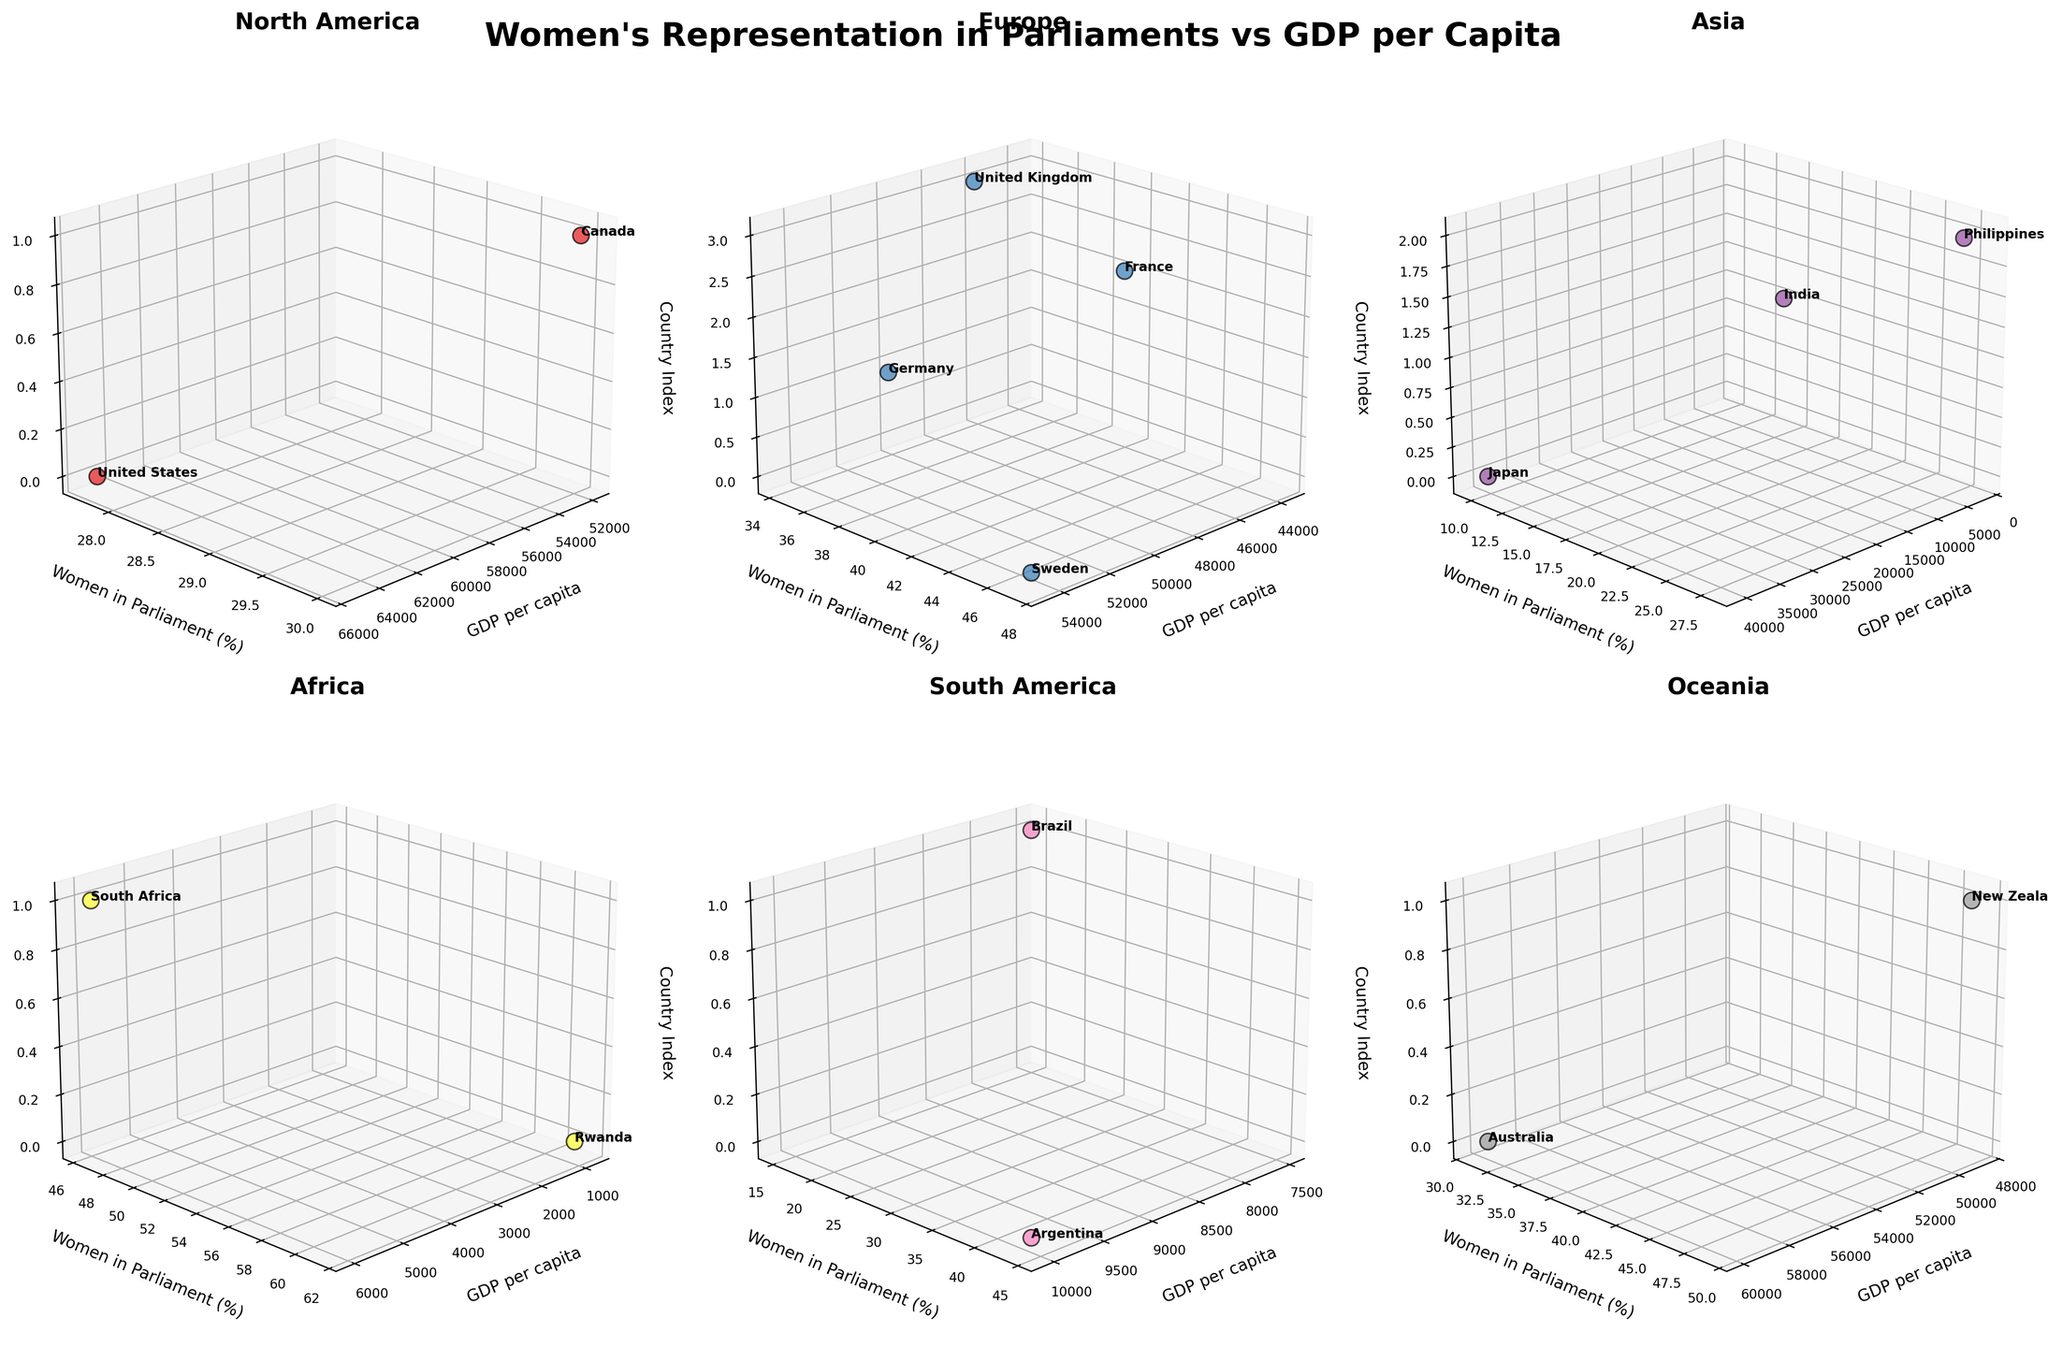What is the title of the figure? The title can be found at the top center of the figure. It reads "Women's Representation in Parliaments vs GDP per Capita".
Answer: Women's Representation in Parliaments vs GDP per Capita How many continents are represented in the figure? Count the number of subplots, each representing a different continent. There are 6 subplots.
Answer: 6 Which continent has the country with the highest percentage of women in parliament? By looking at the Y-axis labeled "Women in Parliament (%)" across all subplots, Rwanda in Africa has the highest percentage at 61.3%.
Answer: Africa Which continent has the highest GDP per capita? By examining the X-axis labeled "GDP per capita" across all subplots, North America has the highest GDP per capita with the United States at 65297 USD.
Answer: North America Which two countries in Europe have the closest percentage of women in parliament? By comparing the Y-axis values in the Europe subplot, Germany (34.9%) and United Kingdom (34.3%) are the closest.
Answer: Germany and United Kingdom What is the average GDP per capita for the countries in Asia represented in the plot? Sum the GDP per capita values for Japan (40193), India (2256), and Philippines (3549), then divide by 3: (40193 + 2256 + 3549) / 3.
Answer: (40193 + 2256 + 3549) / 3 = 15332.67 Which country in South America has a higher percentage of women in parliament? By comparing the Y-axis values in the South America subplot, Argentina (44.4%) has a higher percentage than Brazil (15.2%).
Answer: Argentina Which continent has the widest range of women in parliament percentages among its countries? Compare the range (maximum percentage minus minimum percentage) of Y-axis values in each subplot. Africa's range (61.3% - 46.4%) is the widest.
Answer: Africa Which country in Oceania has a higher GDP per capita? By comparing the X-axis values in the Oceania subplot, Australia (59934) has a higher GDP per capita than New Zealand (48781).
Answer: Australia What is the percentage of women in parliament in the United States? The United States is represented in the North America subplot, and its Y-axis value is 27.7%.
Answer: 27.7% 